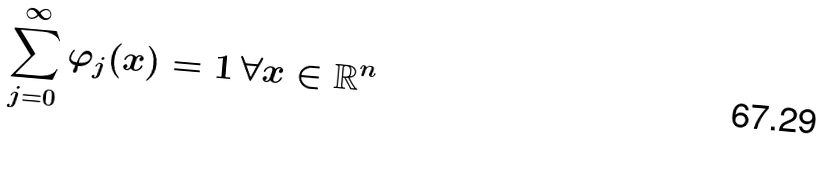<formula> <loc_0><loc_0><loc_500><loc_500>\sum _ { j = 0 } ^ { \infty } \varphi _ { j } ( x ) = 1 \, \forall x \in \mathbb { R } ^ { n }</formula> 